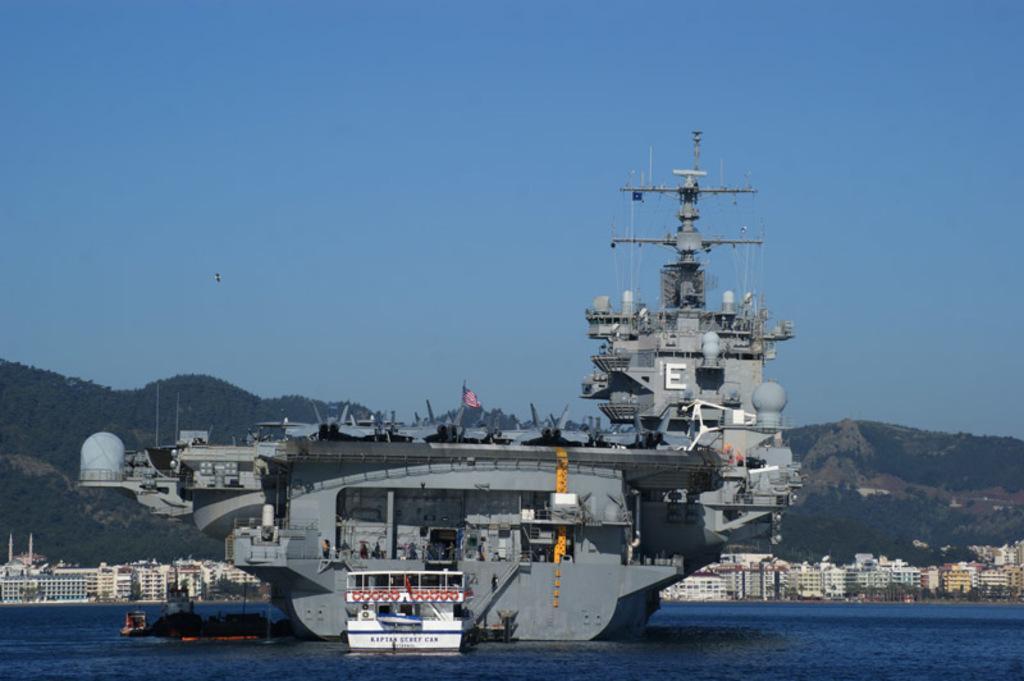In one or two sentences, can you explain what this image depicts? In this picture we can see a ship in the water. There is a flag on this ship. We can see few buildings and trees in the background. 